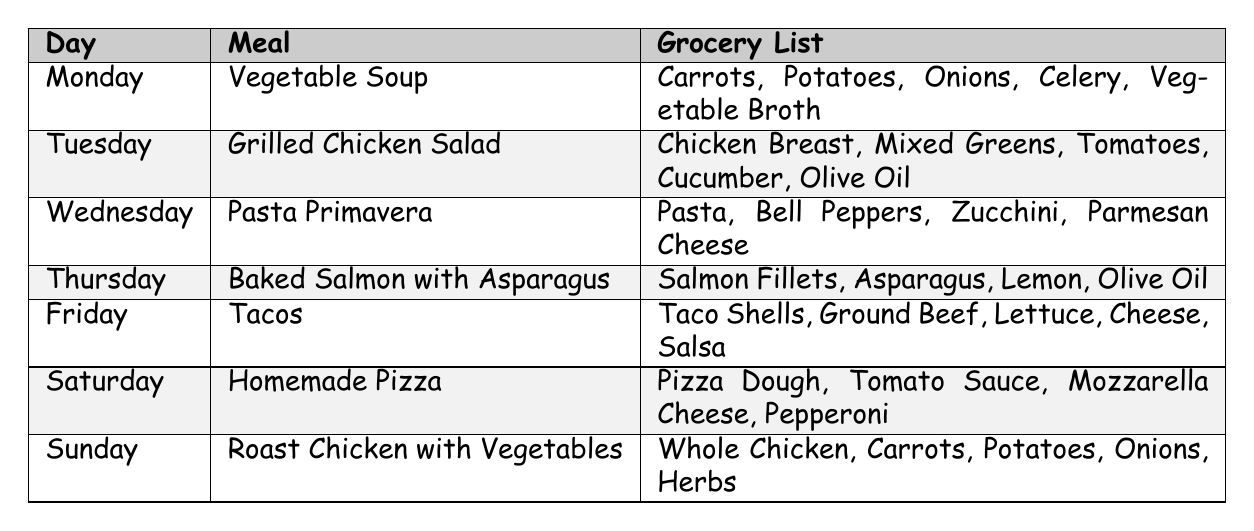What meal is planned for Wednesday? The table lists the meal for Wednesday as "Pasta Primavera".
Answer: Pasta Primavera How many ingredients are needed for Friday's meal? The table shows that Friday's meal, "Tacos", requires five ingredients: Taco Shells, Ground Beef, Lettuce, Cheese, and Salsa.
Answer: Five ingredients Is there a salad meal in the weekly meal plan? Yes, the table indicates that "Grilled Chicken Salad" is the meal planned for Tuesday.
Answer: Yes Which meal requires salmon? The meal that requires salmon is "Baked Salmon with Asparagus," which is planned for Thursday.
Answer: Baked Salmon with Asparagus What are the grocery items needed to make Homemade Pizza? The ingredients listed for "Homemade Pizza" include Pizza Dough, Tomato Sauce, Mozzarella Cheese, and Pepperoni.
Answer: Pizza Dough, Tomato Sauce, Mozzarella Cheese, Pepperoni Which day has the same grocery item as Monday's meal? Both Monday and Sunday require "Carrots" and "Potatoes" for their meals, which are Vegetable Soup and Roast Chicken with Vegetables, respectively.
Answer: Monday and Sunday How many meals include vegetables in their ingredients? The meals with vegetables in their ingredients are "Vegetable Soup," "Grilled Chicken Salad," "Pasta Primavera," and "Roast Chicken with Vegetables," making a total of four meals.
Answer: Four meals If I want to make a dish with chicken, which meals can I choose from? The meals that include chicken are "Grilled Chicken Salad" on Tuesday and "Roast Chicken with Vegetables" on Sunday.
Answer: Two meals What is the most complex meal in terms of ingredient count? "Tacos" on Friday has five ingredients, which is the maximum compared to other meals listed in the table.
Answer: Tacos On which day is the meal with the highest protein likely to be served? "Baked Salmon with Asparagus" on Thursday likely has the highest protein content due to the salmon, as compared to other meals.
Answer: Thursday 